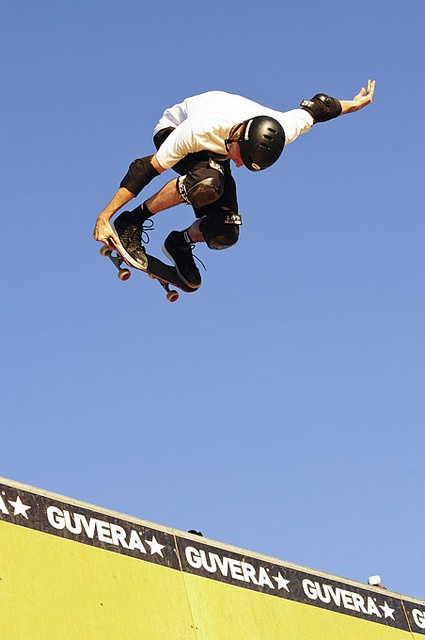Describe the objects in this image and their specific colors. I can see people in gray, black, white, and maroon tones and skateboard in gray, black, maroon, and ivory tones in this image. 